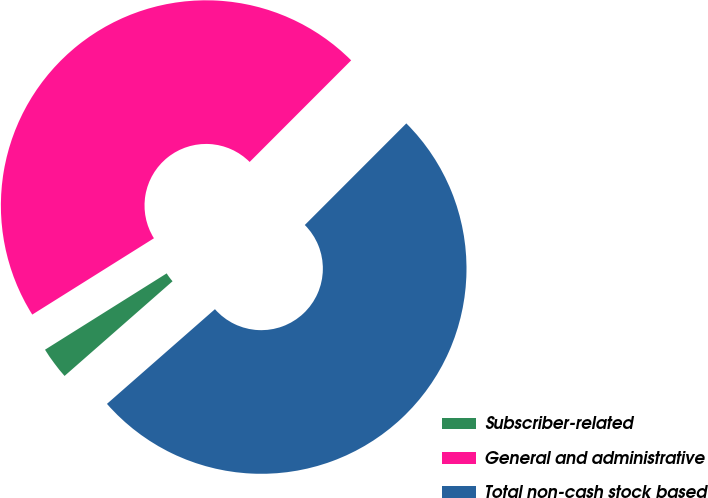Convert chart to OTSL. <chart><loc_0><loc_0><loc_500><loc_500><pie_chart><fcel>Subscriber-related<fcel>General and administrative<fcel>Total non-cash stock based<nl><fcel>2.54%<fcel>46.41%<fcel>51.05%<nl></chart> 